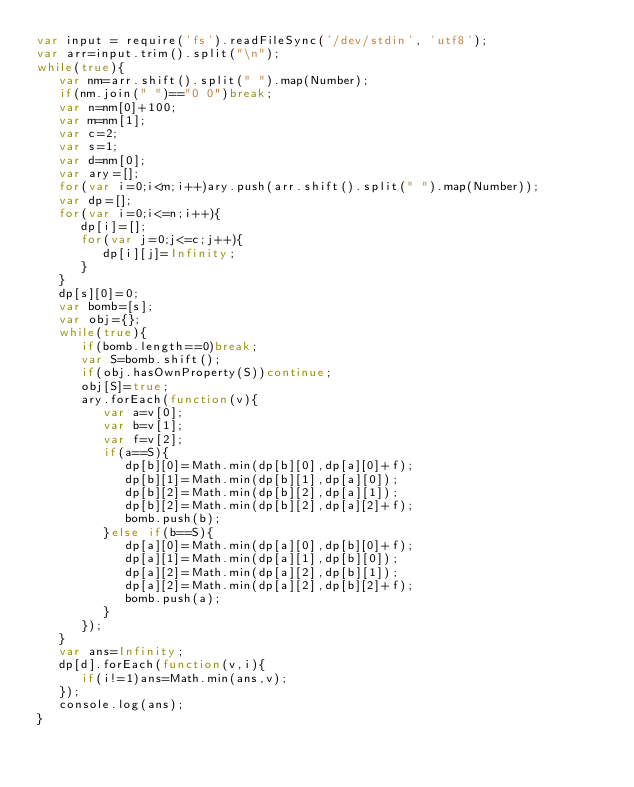Convert code to text. <code><loc_0><loc_0><loc_500><loc_500><_JavaScript_>var input = require('fs').readFileSync('/dev/stdin', 'utf8');
var arr=input.trim().split("\n");
while(true){
   var nm=arr.shift().split(" ").map(Number);
   if(nm.join(" ")=="0 0")break;
   var n=nm[0]+100;
   var m=nm[1];
   var c=2;
   var s=1;
   var d=nm[0];
   var ary=[];
   for(var i=0;i<m;i++)ary.push(arr.shift().split(" ").map(Number));
   var dp=[];
   for(var i=0;i<=n;i++){
      dp[i]=[];
      for(var j=0;j<=c;j++){
         dp[i][j]=Infinity;
      }
   }
   dp[s][0]=0;
   var bomb=[s];
   var obj={};
   while(true){
      if(bomb.length==0)break;
      var S=bomb.shift();
      if(obj.hasOwnProperty(S))continue;
      obj[S]=true;
      ary.forEach(function(v){
         var a=v[0];
         var b=v[1];
         var f=v[2];
         if(a==S){
            dp[b][0]=Math.min(dp[b][0],dp[a][0]+f);
            dp[b][1]=Math.min(dp[b][1],dp[a][0]);
            dp[b][2]=Math.min(dp[b][2],dp[a][1]);
            dp[b][2]=Math.min(dp[b][2],dp[a][2]+f);
            bomb.push(b);
         }else if(b==S){
            dp[a][0]=Math.min(dp[a][0],dp[b][0]+f);
            dp[a][1]=Math.min(dp[a][1],dp[b][0]);
            dp[a][2]=Math.min(dp[a][2],dp[b][1]);
            dp[a][2]=Math.min(dp[a][2],dp[b][2]+f);
            bomb.push(a);
         }
      });
   }
   var ans=Infinity;
   dp[d].forEach(function(v,i){
      if(i!=1)ans=Math.min(ans,v);
   });
   console.log(ans);
}</code> 